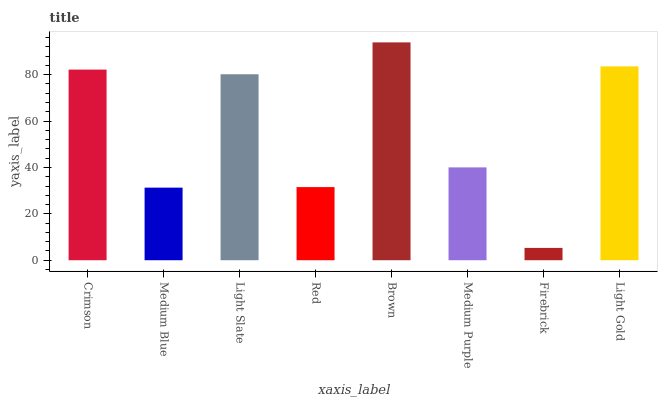Is Firebrick the minimum?
Answer yes or no. Yes. Is Brown the maximum?
Answer yes or no. Yes. Is Medium Blue the minimum?
Answer yes or no. No. Is Medium Blue the maximum?
Answer yes or no. No. Is Crimson greater than Medium Blue?
Answer yes or no. Yes. Is Medium Blue less than Crimson?
Answer yes or no. Yes. Is Medium Blue greater than Crimson?
Answer yes or no. No. Is Crimson less than Medium Blue?
Answer yes or no. No. Is Light Slate the high median?
Answer yes or no. Yes. Is Medium Purple the low median?
Answer yes or no. Yes. Is Crimson the high median?
Answer yes or no. No. Is Brown the low median?
Answer yes or no. No. 